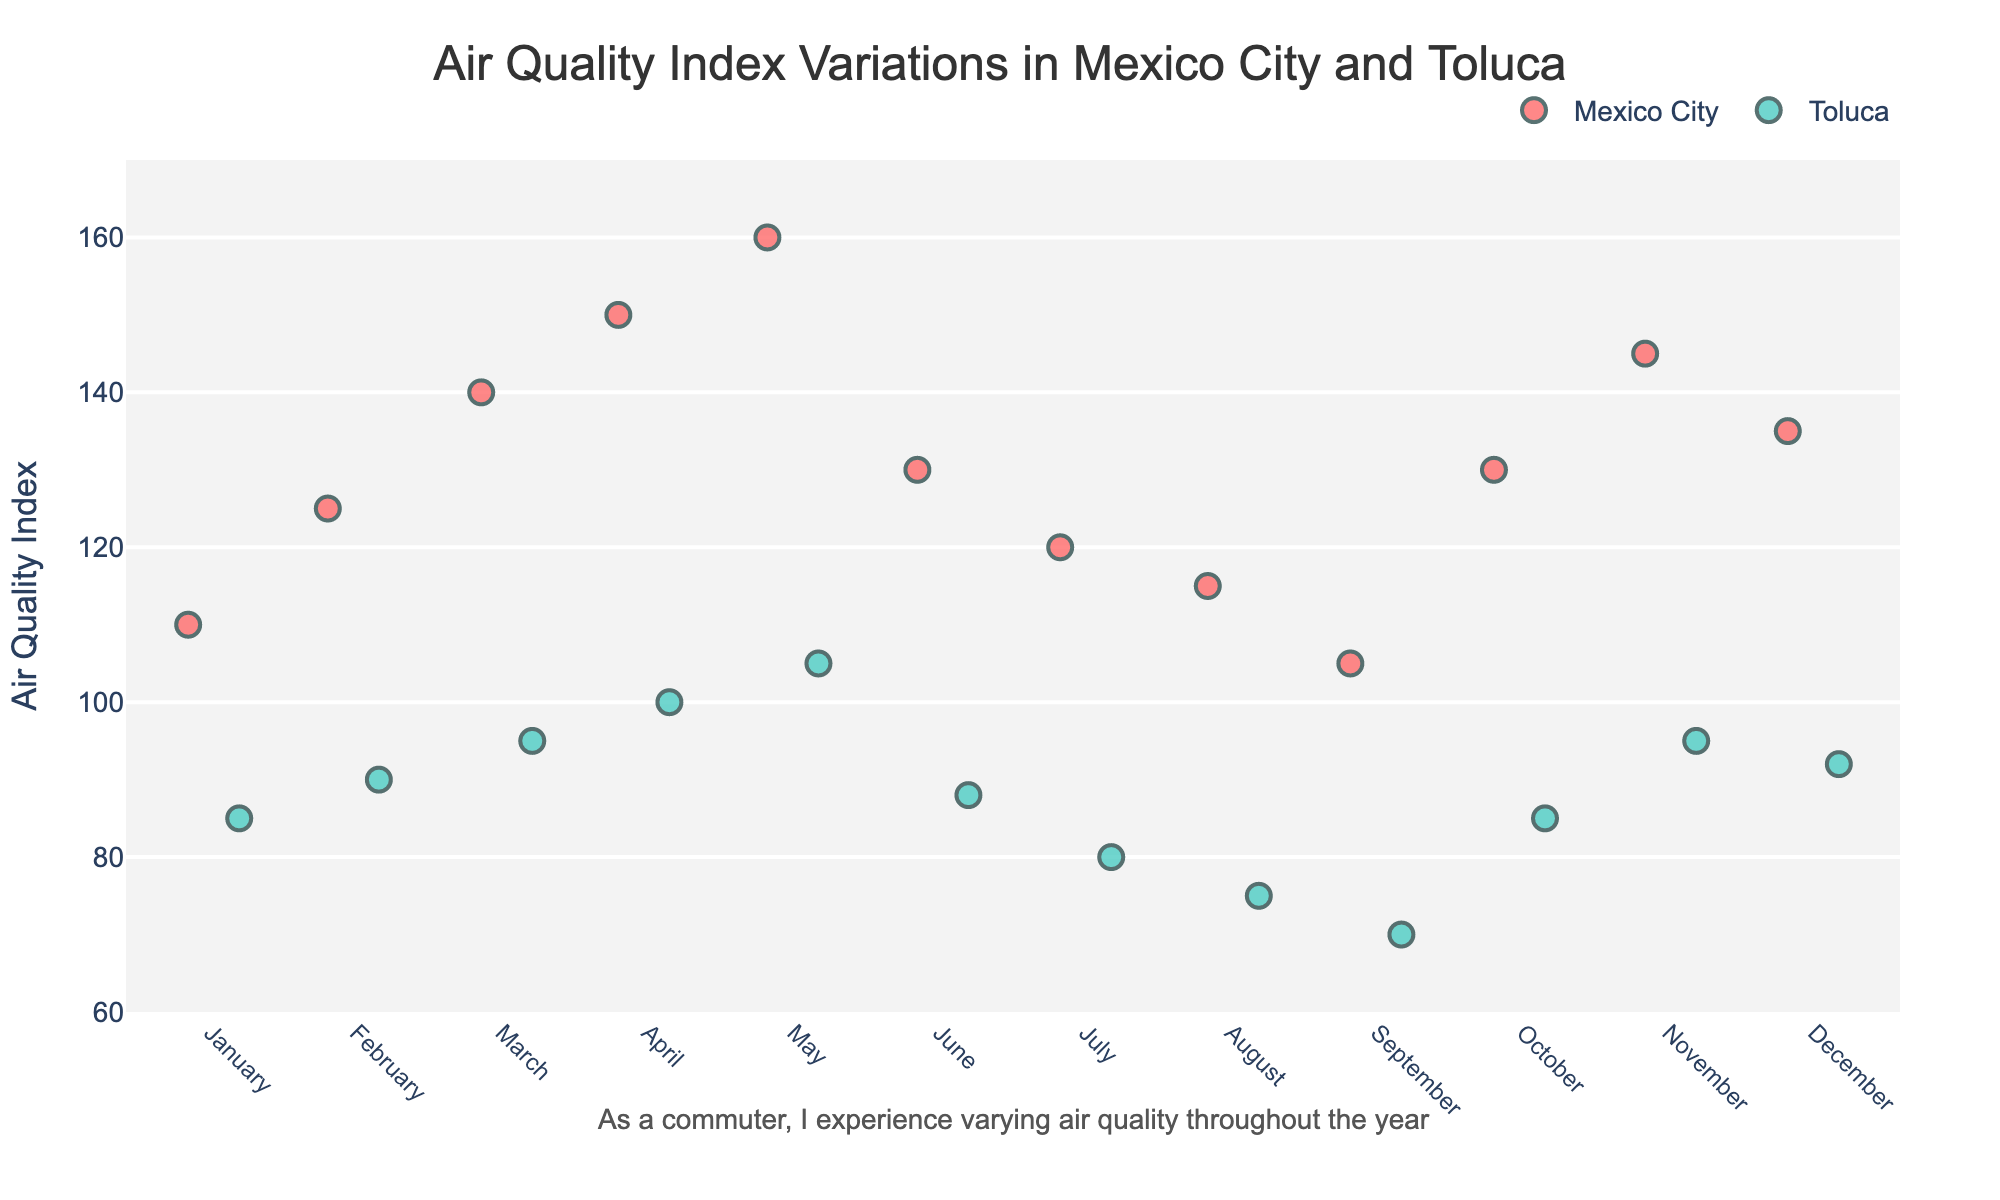What month has the highest AQI in Mexico City? By observing the plot, the highest visible point for Mexico City is in May. This suggests that May is the month with the highest AQI.
Answer: May How does the AQI in Toluca in March compare to the AQI in Mexico City in March? In March, the point representing Toluca is below the point representing Mexico City. Specifically, Toluca's AQI is 95, whereas Mexico City's AQI is 140.
Answer: Toluca's AQI is significantly lower What is the average AQI in Mexico City across the year? To calculate the average, sum the AQI values for Mexico City across all months (110 + 125 + 140 + 150 + 160 + 130 + 120 + 115 + 105 + 130 + 145 + 135) and then divide by the number of months (12). The sum is 1565, and dividing by 12 gives approximately 130.4.
Answer: 130.4 In which month is the difference between Mexico City and Toluca's AQI the smallest? By comparing the points for each month, the smallest difference appears in January, where Mexico City's AQI is 110 and Toluca's AQI is 85, giving a difference of 25.
Answer: January Which city generally has a better air quality index throughout the year, and how can you tell? Toluca generally has a better AQI as all its data points are lower than Mexico City's corresponding points throughout the year. This consistent pattern indicates Toluca has generally better air quality.
Answer: Toluca What is the range of the AQI values in Toluca? The lowest AQI value for Toluca is in September (70) and the highest is in May (105). The range is the difference between these values, which is 105 - 70 = 35.
Answer: 35 In which month is the disparity between the AQI values of the two cities the most pronounced? By observing the distance between points for each month, the largest disparity appears in May, where Mexico City's AQI is 160 and Toluca's AQI is 105, giving a difference of 55.
Answer: May What month shows an AQI for Toluca below 80? The plot shows that Toluca's AQI is below 80 in August and September, specifically 75 and 70 respectively.
Answer: August and September 